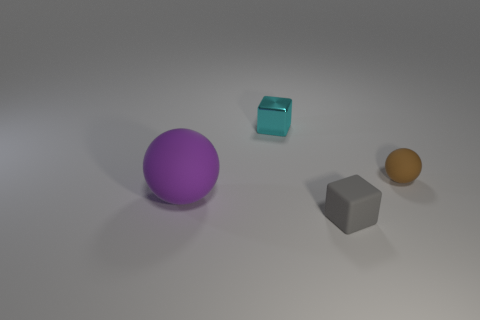What can you infer about the light source in this scene? Based on the shadows in the image, the light source seems to be coming from the top left direction, slightly in front of the objects. 